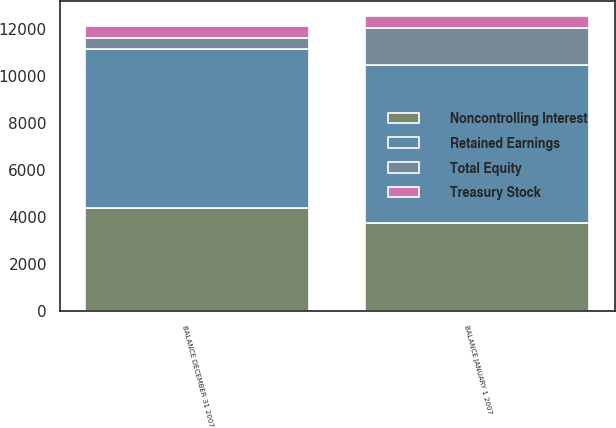Convert chart to OTSL. <chart><loc_0><loc_0><loc_500><loc_500><stacked_bar_chart><ecel><fcel>BALANCE JANUARY 1 2007<fcel>BALANCE DECEMBER 31 2007<nl><fcel>Treasury Stock<fcel>493<fcel>494<nl><fcel>Retained Earnings<fcel>6735<fcel>6755<nl><fcel>Noncontrolling Interest<fcel>3737<fcel>4375<nl><fcel>Total Equity<fcel>1564<fcel>471<nl></chart> 